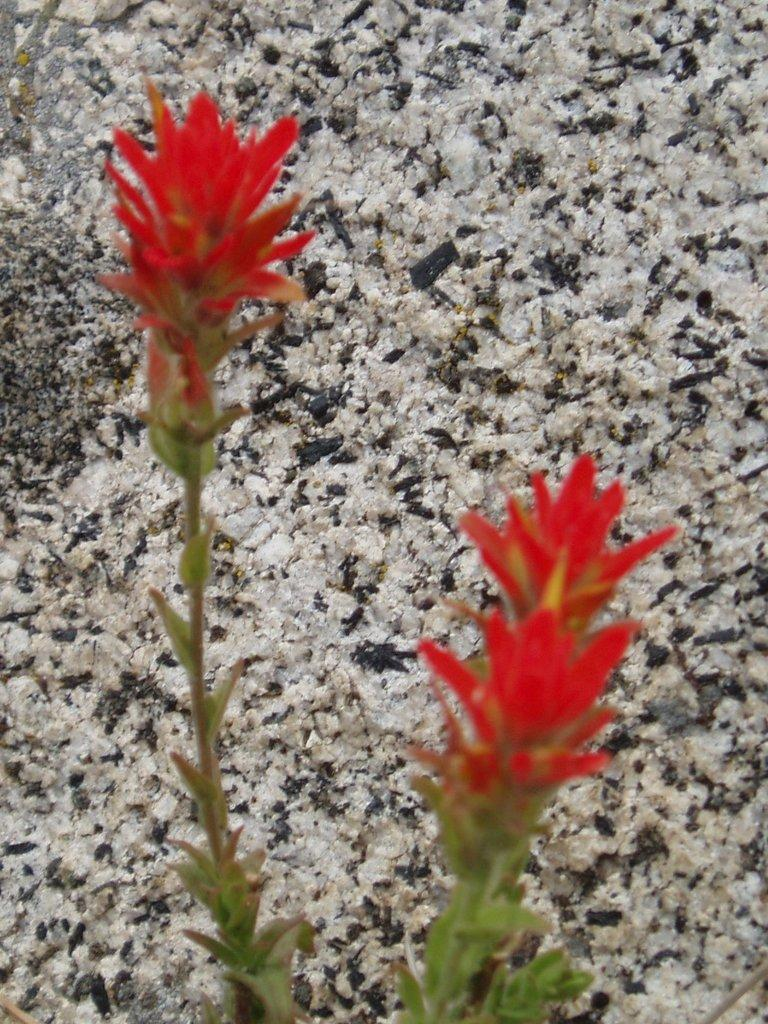What type of living organism is present in the image? There is a plant in the image. What color are the flowers on the plant? The plant has red flowers. What other object can be seen in the image besides the plant? There appears to be a rock in the image. Who is the expert on the plant's growth in the image? There is no expert present in the image; it is a photograph of a plant with red flowers and a rock. 